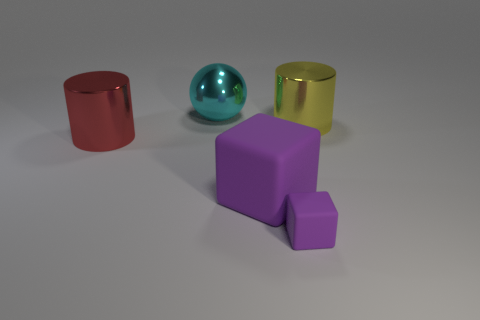What number of other objects are there of the same shape as the small purple thing?
Give a very brief answer. 1. There is a tiny matte block; what number of purple matte things are on the right side of it?
Offer a very short reply. 0. There is a purple matte cube on the left side of the tiny cube; does it have the same size as the matte thing that is to the right of the big purple rubber object?
Your answer should be compact. No. What number of other things are there of the same size as the yellow shiny thing?
Offer a terse response. 3. There is a small block to the left of the big metal cylinder that is behind the shiny object in front of the yellow metal thing; what is its material?
Ensure brevity in your answer.  Rubber. Is the size of the yellow metallic cylinder the same as the metallic object that is to the left of the big cyan ball?
Provide a short and direct response. Yes. What size is the thing that is both on the right side of the large block and in front of the red cylinder?
Offer a terse response. Small. Is there another ball of the same color as the large ball?
Keep it short and to the point. No. What is the color of the block right of the rubber cube left of the small matte object?
Provide a short and direct response. Purple. Is the number of red objects that are to the right of the yellow metal thing less than the number of spheres right of the red cylinder?
Your answer should be compact. Yes. 